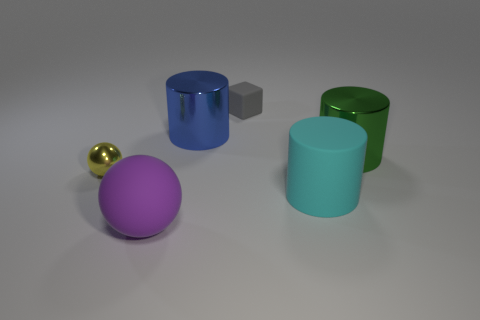Are there any big things behind the large matte thing that is behind the big purple ball?
Offer a terse response. Yes. There is a purple rubber ball; are there any green cylinders left of it?
Keep it short and to the point. No. Do the small object right of the large purple ball and the blue thing have the same shape?
Provide a short and direct response. No. What number of other small blue rubber objects have the same shape as the blue object?
Make the answer very short. 0. Is there a large cyan cylinder made of the same material as the gray cube?
Give a very brief answer. Yes. What material is the tiny thing behind the small thing that is to the left of the gray rubber object?
Keep it short and to the point. Rubber. How big is the metallic cylinder behind the green thing?
Your answer should be compact. Large. Does the small block have the same color as the big shiny cylinder left of the big cyan matte thing?
Your answer should be compact. No. Is there a metallic cylinder that has the same color as the large sphere?
Give a very brief answer. No. Is the material of the tiny ball the same as the tiny thing behind the yellow thing?
Ensure brevity in your answer.  No. 